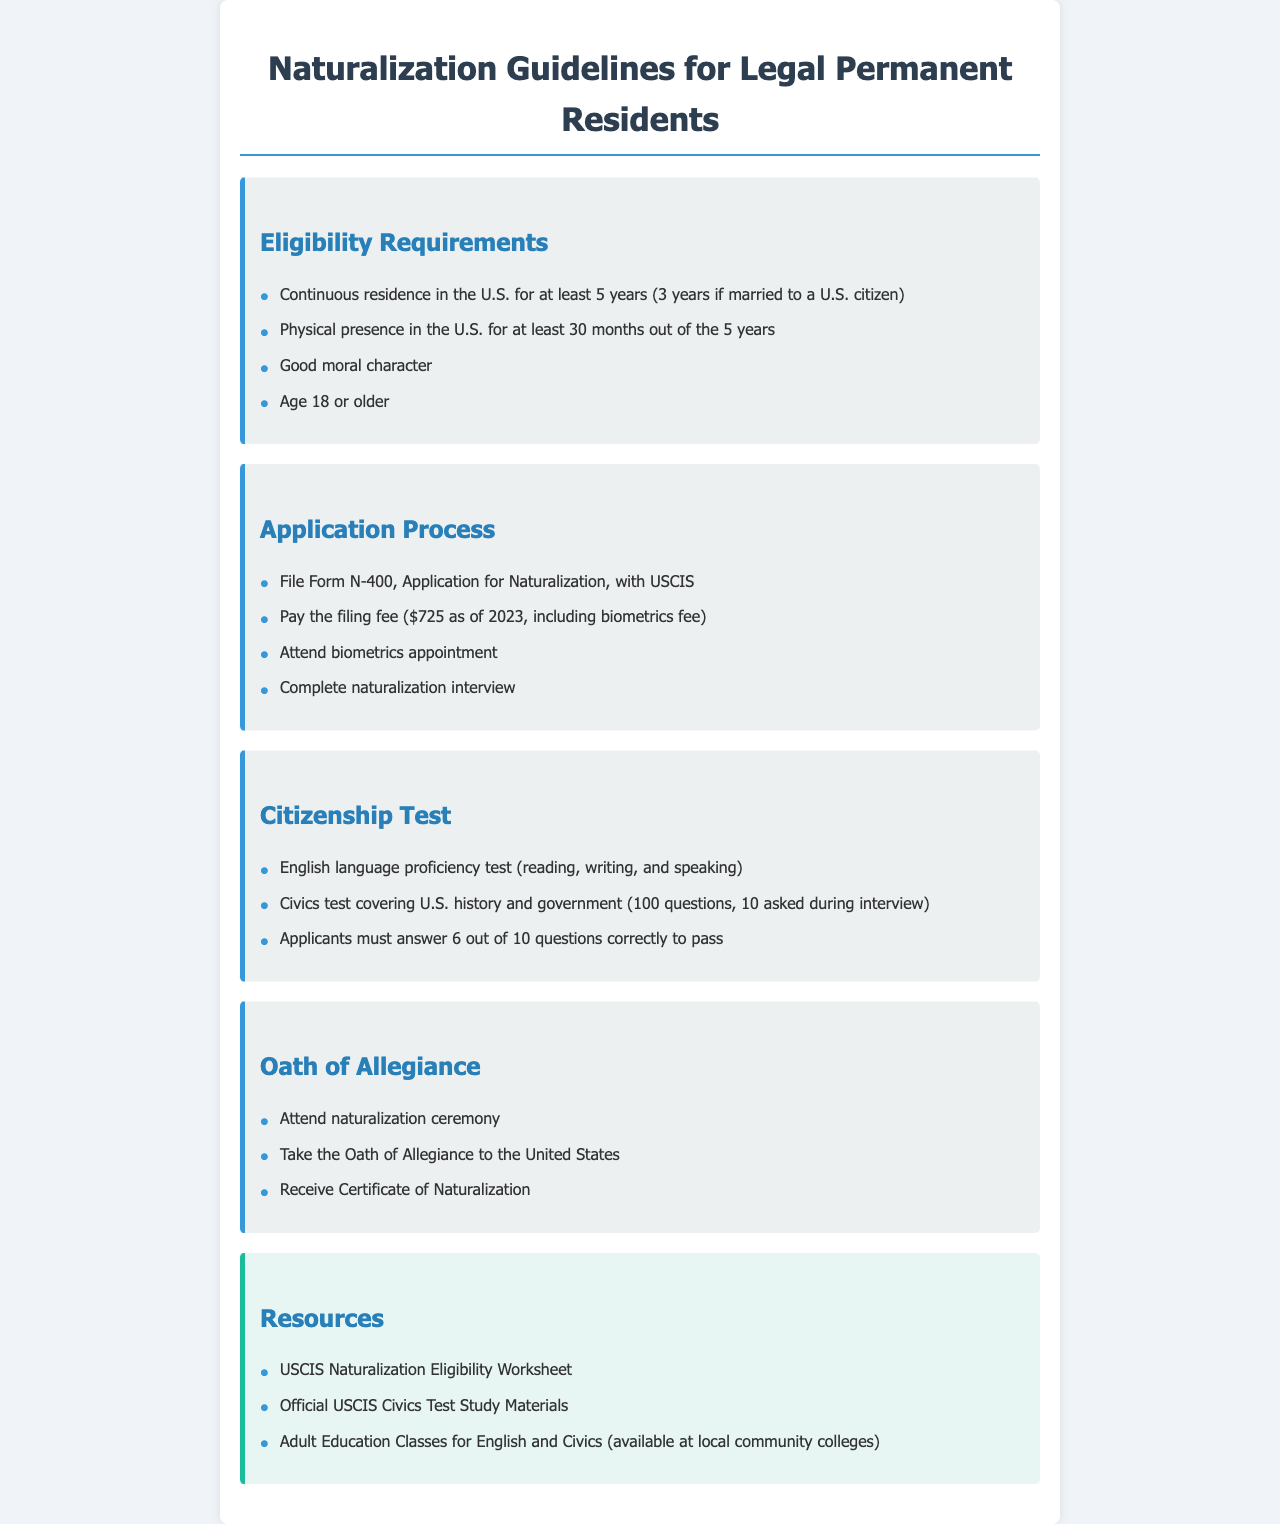what is the required continuous residence in the U.S. for naturalization? Applicants must have continuous residence in the U.S. for a minimum of 5 years.
Answer: 5 years what is the filing fee for the Application for Naturalization? The filing fee for Form N-400 is $725 as of 2023.
Answer: $725 how many months of physical presence in the U.S. are required? Applicants must have physical presence in the U.S. for at least 30 months out of the 5 years.
Answer: 30 months how many questions from the civics test are asked during the interview? During the interview, 10 questions from the civics test will be asked.
Answer: 10 questions what must applicants do to pass the citizenship test? Applicants must answer 6 out of 10 questions correctly to pass.
Answer: 6 questions how old must applicants be to apply for naturalization? Applicants must be at least 18 years old to apply for naturalization.
Answer: 18 years what is the first step in the application process? The first step is to file Form N-400, Application for Naturalization, with USCIS.
Answer: File Form N-400 what do applicants receive after taking the Oath of Allegiance? After taking the Oath of Allegiance, applicants receive a Certificate of Naturalization.
Answer: Certificate of Naturalization what type of test must applicants take for English language proficiency? Applicants must take an English language proficiency test covering reading, writing, and speaking.
Answer: English language proficiency test 